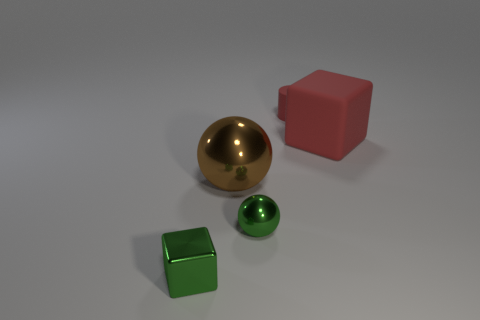What is the shape of the tiny thing that is the same color as the metallic block? The tiny object sharing the same color as the metallic block is spherical in shape, closely resembling a small, polished ball. 